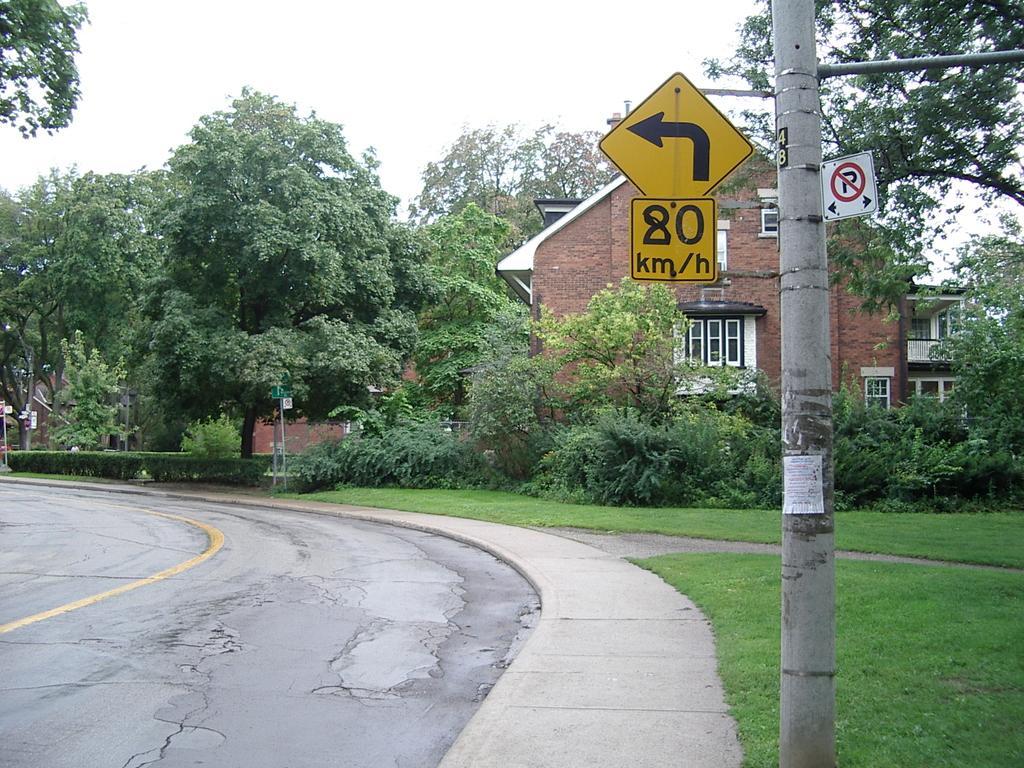How would you summarize this image in a sentence or two? In this image we can see a road. Near to the road there is a sidewalk. On the ground there is grass. On the right side there is a pole. Also there are sign boards. In the back there are trees and a building with windows. In the background there is sky. 